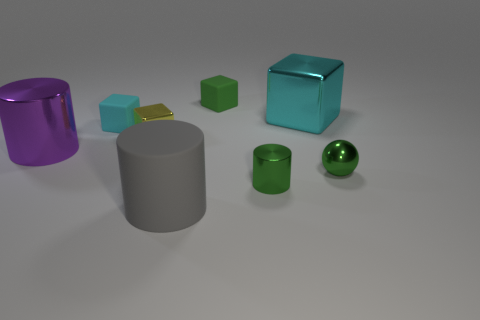What is the color of the block to the right of the green matte cube? cyan 